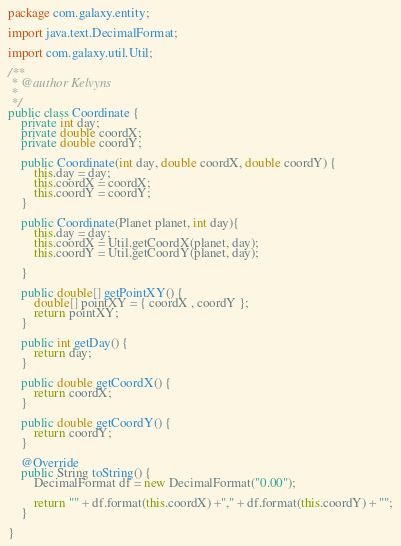Convert code to text. <code><loc_0><loc_0><loc_500><loc_500><_Java_>package com.galaxy.entity;

import java.text.DecimalFormat;

import com.galaxy.util.Util;

/**
 * @author Kelvyns
 *
 */
public class Coordinate {
	private int day;
	private double coordX;
	private double coordY;
	
	public Coordinate(int day, double coordX, double coordY) {
		this.day = day;
		this.coordX = coordX;
		this.coordY = coordY;
	}
	
	public Coordinate(Planet planet, int day){
		this.day = day;
		this.coordX = Util.getCoordX(planet, day);
		this.coordY = Util.getCoordY(planet, day);
		
	}
	
	public double[] getPointXY() {
		double[] pointXY = { coordX , coordY };
		return pointXY;
	}

	public int getDay() {
		return day;
	}

	public double getCoordX() {
		return coordX;
	}

	public double getCoordY() {
		return coordY;
	}
	
	@Override
	public String toString() {
		DecimalFormat df = new DecimalFormat("0.00");
		
		return "" + df.format(this.coordX) +"," + df.format(this.coordY) + "";
	}

}
</code> 